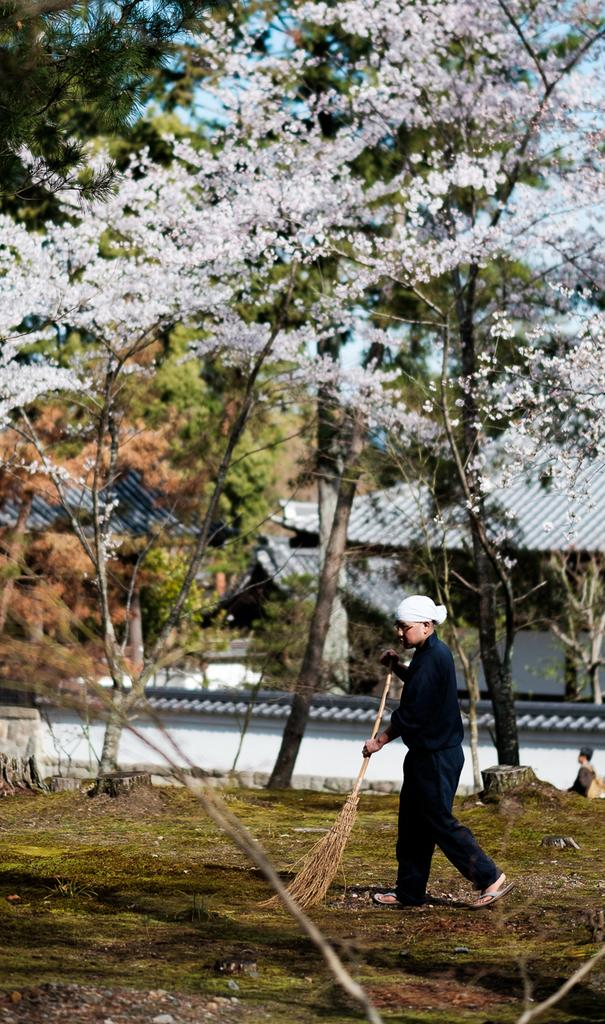Who is the main subject in the image? There is a boy in the image. What is the boy wearing? The boy is wearing a black t-shirt and pants. What is the boy holding in the image? The boy is holding a broomstick. What is the boy doing with the broomstick? The boy is cleaning the grasslands with the broomstick. What can be seen in the background of the image? There are shed houses and trees in the background of the image. What type of linen is being exchanged between the houses in the image? There is no exchange of linen or any other items between the houses in the image. The image only shows a boy cleaning the grasslands with a broomstick, and there are shed houses and trees in the background. 